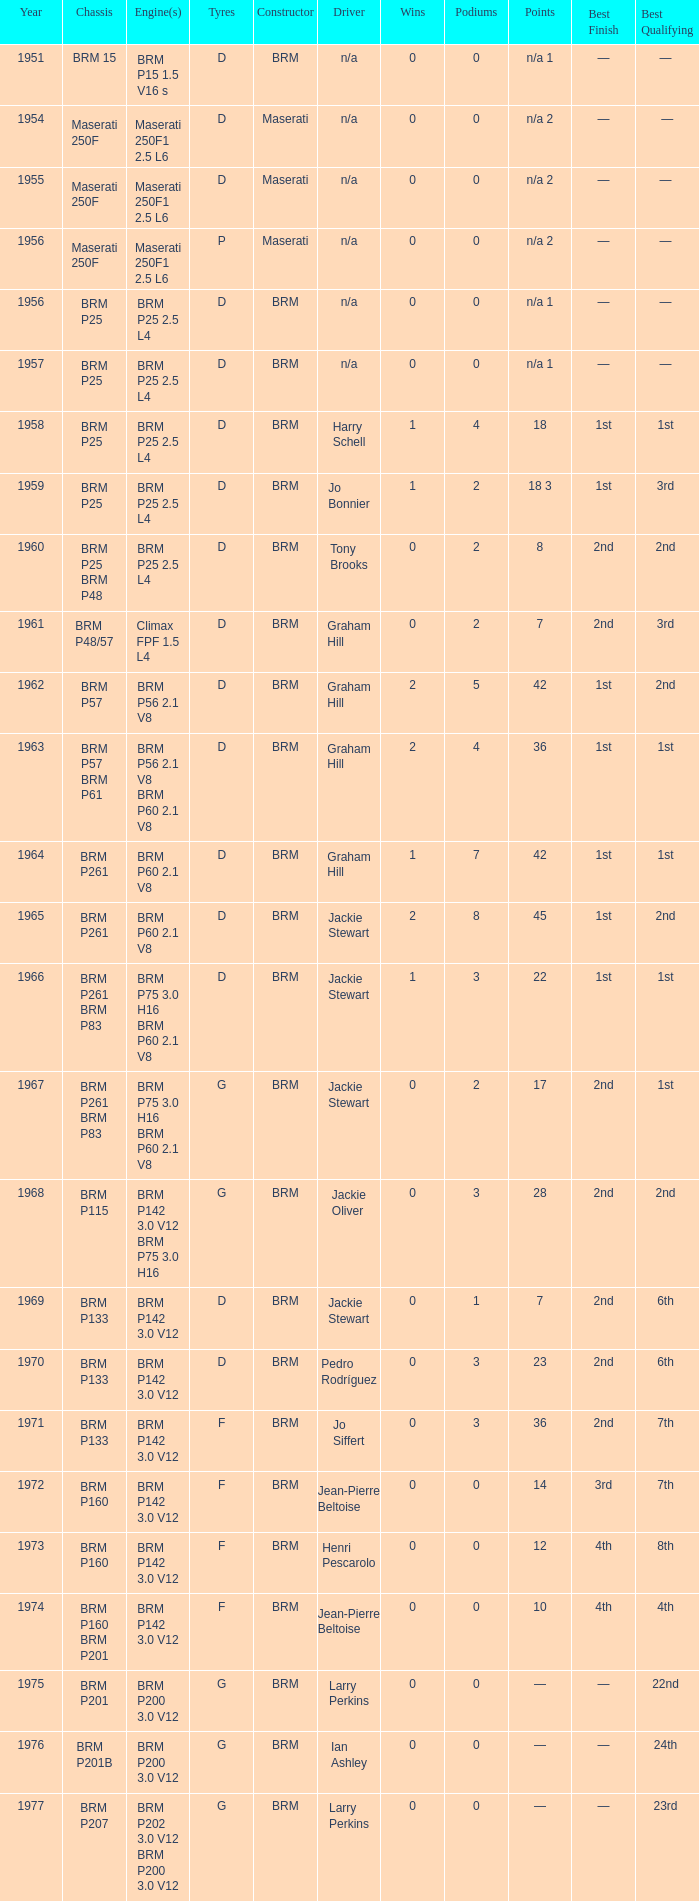Could you help me parse every detail presented in this table? {'header': ['Year', 'Chassis', 'Engine(s)', 'Tyres', 'Constructor', 'Driver', 'Wins', 'Podiums', 'Points', 'Best Finish', 'Best Qualifying '], 'rows': [['1951', 'BRM 15', 'BRM P15 1.5 V16 s', 'D', 'BRM', 'n/a', '0', '0', 'n/a 1', '—', '— '], ['1954', 'Maserati 250F', 'Maserati 250F1 2.5 L6', 'D', 'Maserati', 'n/a', '0', '0', 'n/a 2', '—', '—'], ['1955', 'Maserati 250F', 'Maserati 250F1 2.5 L6', 'D', 'Maserati', 'n/a', '0', '0', 'n/a 2', '—', '— '], ['1956', 'Maserati 250F', 'Maserati 250F1 2.5 L6', 'P', 'Maserati', 'n/a', '0', '0', 'n/a 2', '—', '— '], ['1956', 'BRM P25', 'BRM P25 2.5 L4', 'D', 'BRM', 'n/a', '0', '0', 'n/a 1', '—', '— '], ['1957', 'BRM P25', 'BRM P25 2.5 L4', 'D', 'BRM', 'n/a', '0', '0', 'n/a 1', '—', '— '], ['1958', 'BRM P25', 'BRM P25 2.5 L4', 'D', 'BRM', 'Harry Schell', '1', '4', '18', '1st', '1st '], ['1959', 'BRM P25', 'BRM P25 2.5 L4', 'D', 'BRM', 'Jo Bonnier', '1', '2', '18 3', '1st', '3rd '], ['1960', 'BRM P25 BRM P48', 'BRM P25 2.5 L4', 'D', 'BRM', 'Tony Brooks', '0', '2', '8', '2nd', '2nd '], ['1961', 'BRM P48/57', 'Climax FPF 1.5 L4', 'D', 'BRM', 'Graham Hill', '0', '2', '7', '2nd', '3rd '], ['1962', 'BRM P57', 'BRM P56 2.1 V8', 'D', 'BRM', 'Graham Hill', '2', '5', '42', '1st', '2nd '], ['1963', 'BRM P57 BRM P61', 'BRM P56 2.1 V8 BRM P60 2.1 V8', 'D', 'BRM', 'Graham Hill', '2', '4', '36', '1st', '1st '], ['1964', 'BRM P261', 'BRM P60 2.1 V8', 'D', 'BRM', 'Graham Hill', '1', '7', '42', '1st', '1st '], ['1965', 'BRM P261', 'BRM P60 2.1 V8', 'D', 'BRM', 'Jackie Stewart', '2', '8', '45', '1st', '2nd '], ['1966', 'BRM P261 BRM P83', 'BRM P75 3.0 H16 BRM P60 2.1 V8', 'D', 'BRM', 'Jackie Stewart', '1', '3', '22', '1st', '1st '], ['1967', 'BRM P261 BRM P83', 'BRM P75 3.0 H16 BRM P60 2.1 V8', 'G', 'BRM', 'Jackie Stewart', '0', '2', '17', '2nd', '1st '], ['1968', 'BRM P115', 'BRM P142 3.0 V12 BRM P75 3.0 H16', 'G', 'BRM', 'Jackie Oliver', '0', '3', '28', '2nd', '2nd '], ['1969', 'BRM P133', 'BRM P142 3.0 V12', 'D', 'BRM', 'Jackie Stewart', '0', '1', '7', '2nd', '6th '], ['1970', 'BRM P133', 'BRM P142 3.0 V12', 'D', 'BRM', 'Pedro Rodríguez', '0', '3', '23', '2nd', '6th '], ['1971', 'BRM P133', 'BRM P142 3.0 V12', 'F', 'BRM', 'Jo Siffert', '0', '3', '36', '2nd', '7th '], ['1972', 'BRM P160', 'BRM P142 3.0 V12', 'F', 'BRM', 'Jean-Pierre Beltoise', '0', '0', '14', '3rd', '7th '], ['1973', 'BRM P160', 'BRM P142 3.0 V12', 'F', 'BRM', 'Henri Pescarolo', '0', '0', '12', '4th', '8th '], ['1974', 'BRM P160 BRM P201', 'BRM P142 3.0 V12', 'F', 'BRM', 'Jean-Pierre Beltoise', '0', '0', '10', '4th', '4th '], ['1975', 'BRM P201', 'BRM P200 3.0 V12', 'G', 'BRM', 'Larry Perkins', '0', '0', '—', '—', '22nd '], ['1976', 'BRM P201B', 'BRM P200 3.0 V12', 'G', 'BRM', 'Ian Ashley', '0', '0', '—', '—', '24th '], ['1977', 'BRM P207', 'BRM P202 3.0 V12 BRM P200 3.0 V12', 'G', 'BRM', 'Larry Perkins', '0', '0', '—', '—', '23rd ']]} Name the point for 1974 10.0. 